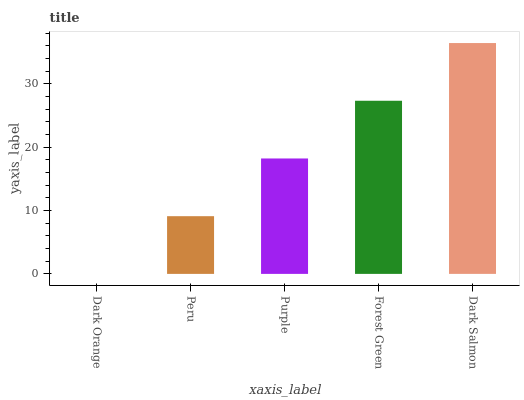Is Dark Orange the minimum?
Answer yes or no. Yes. Is Dark Salmon the maximum?
Answer yes or no. Yes. Is Peru the minimum?
Answer yes or no. No. Is Peru the maximum?
Answer yes or no. No. Is Peru greater than Dark Orange?
Answer yes or no. Yes. Is Dark Orange less than Peru?
Answer yes or no. Yes. Is Dark Orange greater than Peru?
Answer yes or no. No. Is Peru less than Dark Orange?
Answer yes or no. No. Is Purple the high median?
Answer yes or no. Yes. Is Purple the low median?
Answer yes or no. Yes. Is Dark Salmon the high median?
Answer yes or no. No. Is Forest Green the low median?
Answer yes or no. No. 